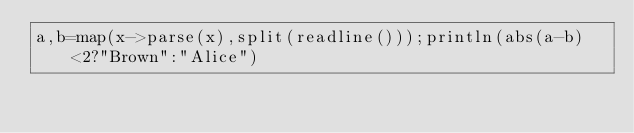<code> <loc_0><loc_0><loc_500><loc_500><_Julia_>a,b=map(x->parse(x),split(readline()));println(abs(a-b)<2?"Brown":"Alice")</code> 